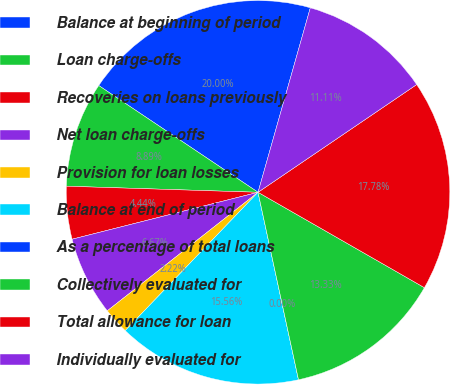<chart> <loc_0><loc_0><loc_500><loc_500><pie_chart><fcel>Balance at beginning of period<fcel>Loan charge-offs<fcel>Recoveries on loans previously<fcel>Net loan charge-offs<fcel>Provision for loan losses<fcel>Balance at end of period<fcel>As a percentage of total loans<fcel>Collectively evaluated for<fcel>Total allowance for loan<fcel>Individually evaluated for<nl><fcel>20.0%<fcel>8.89%<fcel>4.44%<fcel>6.67%<fcel>2.22%<fcel>15.56%<fcel>0.0%<fcel>13.33%<fcel>17.78%<fcel>11.11%<nl></chart> 